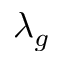Convert formula to latex. <formula><loc_0><loc_0><loc_500><loc_500>\lambda _ { g }</formula> 